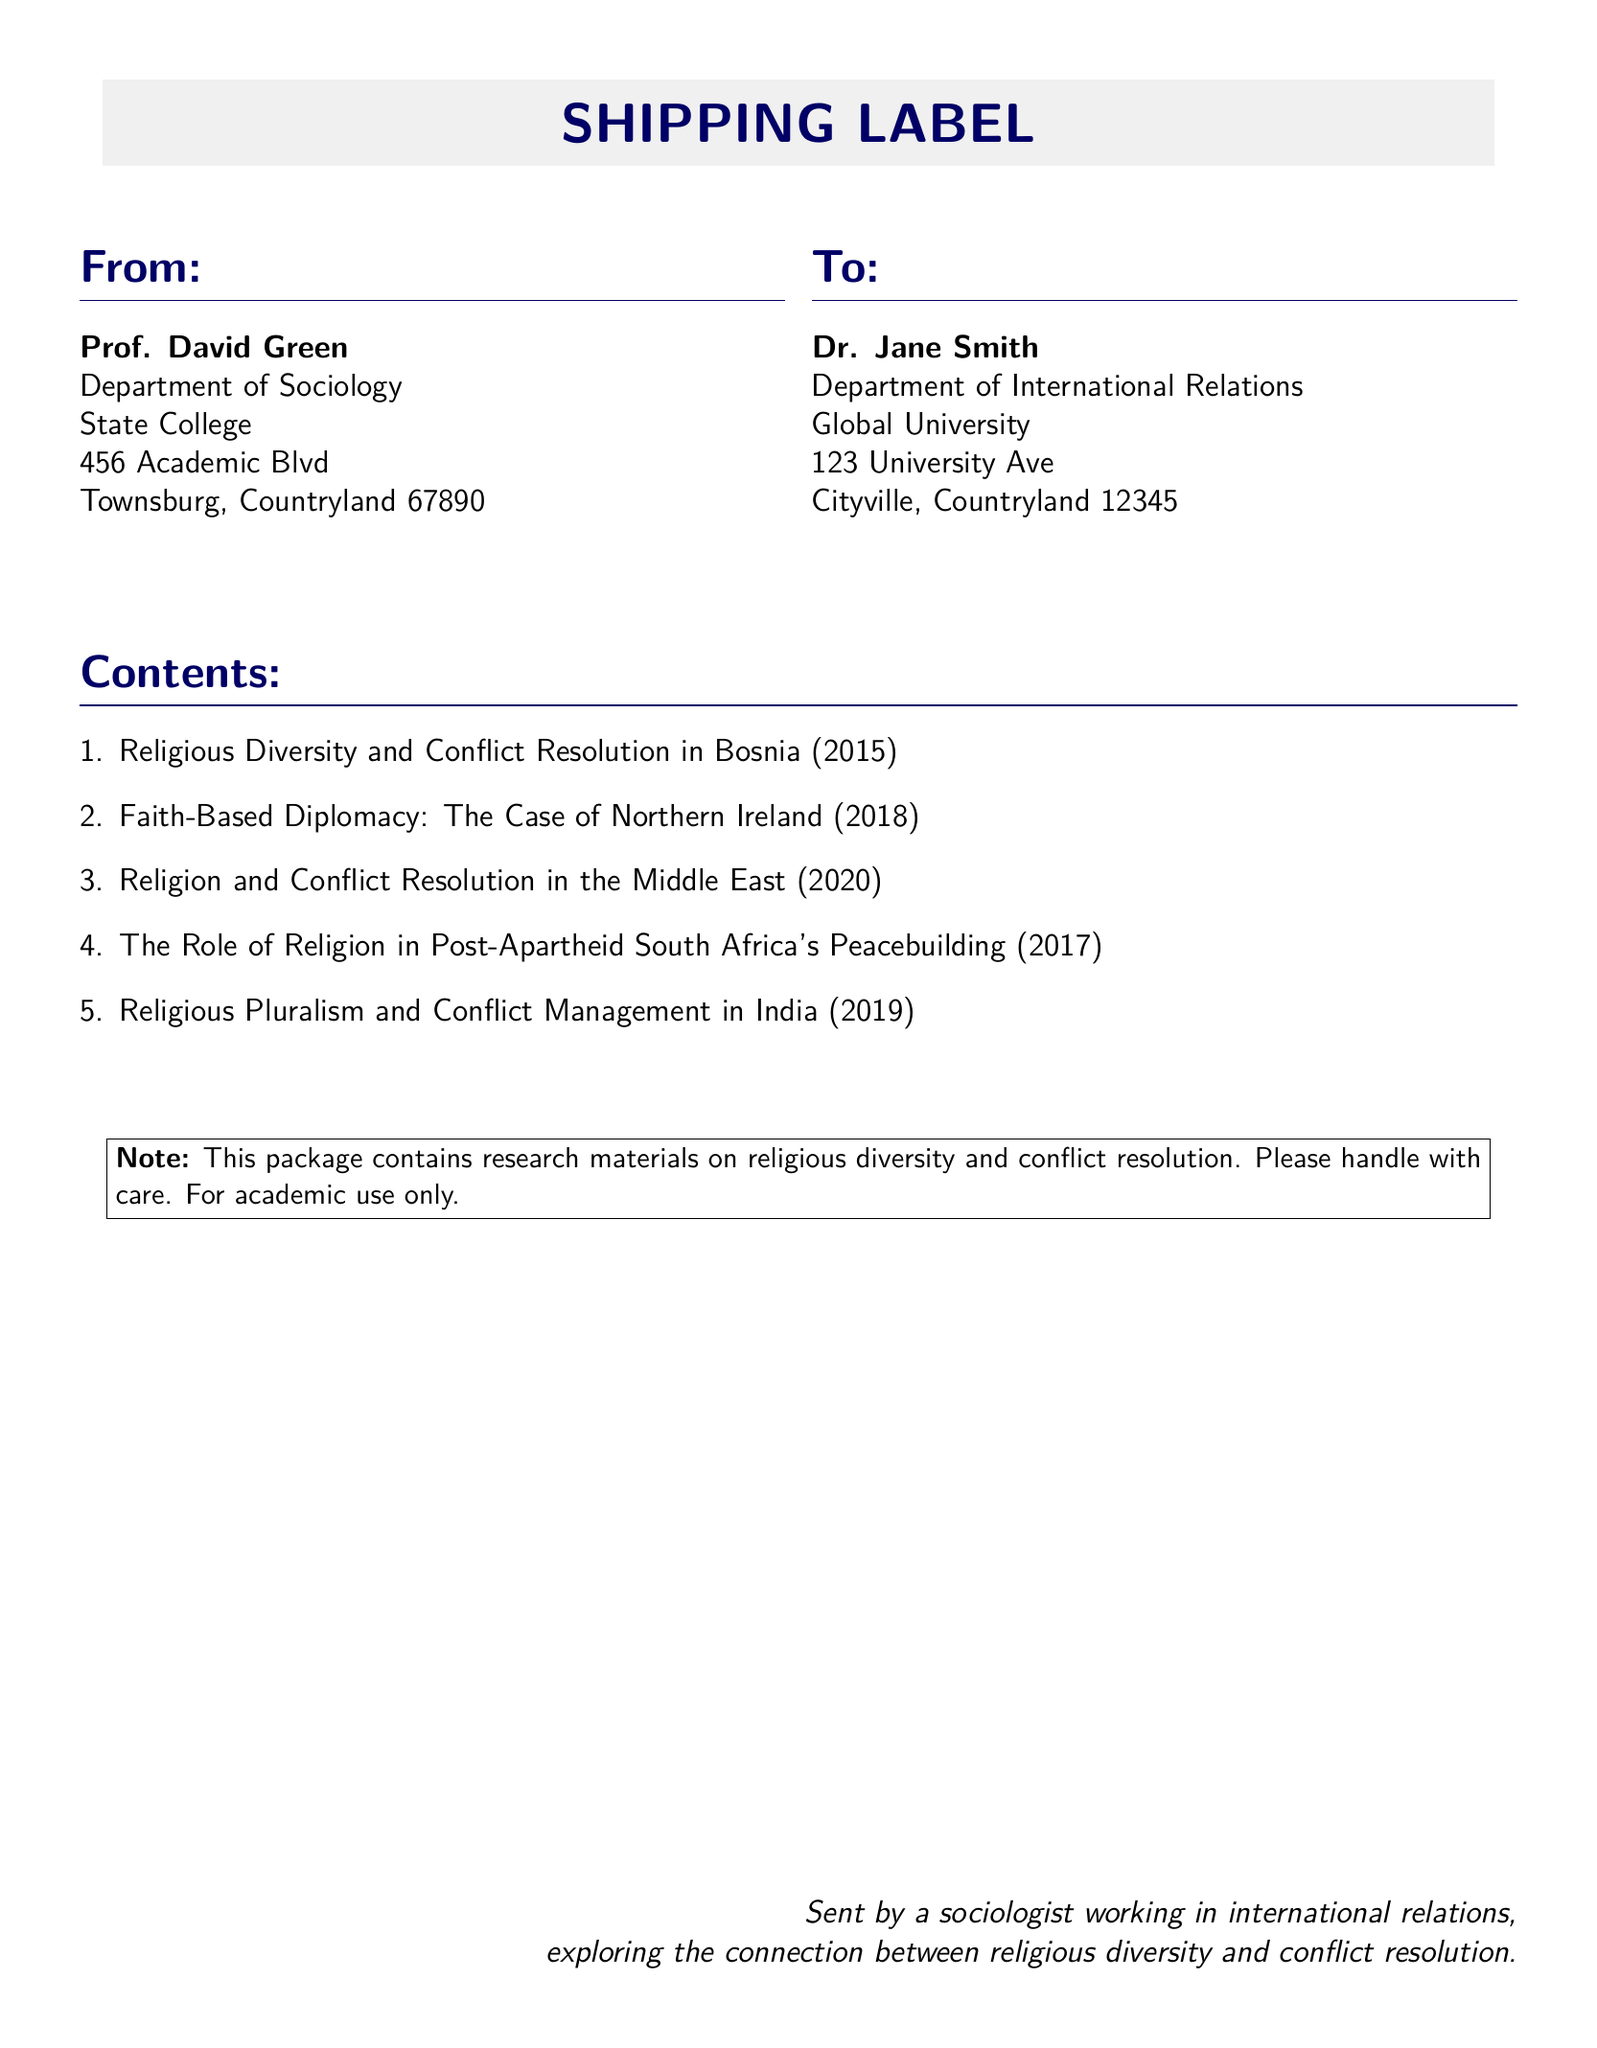What is the sender's name? The sender's name is mentioned at the top of the document under "From," which is Prof. David Green.
Answer: Prof. David Green What is the recipient's name? The recipient's name is noted under "To," which is Dr. Jane Smith.
Answer: Dr. Jane Smith How many research papers are included in the shipment? The number of research papers can be counted in the "Contents" section, which lists five papers.
Answer: 5 What is the title of the research paper about Northern Ireland? The title that refers specifically to Northern Ireland is mentioned in the "Contents" section.
Answer: Faith-Based Diplomacy: The Case of Northern Ireland What year was the paper on religious pluralism in India published? The year is found next to the title in the "Contents," indicating when each paper was published.
Answer: 2019 What is the note's purpose included in the document? The note clearly indicates the intended use of the contents, emphasizing handling with care and academic usage.
Answer: For academic use only What department does the sender work in? This information is provided in the "From" section, detailing the sender's affiliation.
Answer: Department of Sociology What color is used for the title in the document? The color used for the title is specified in the document format commands.
Answer: Dark blue 